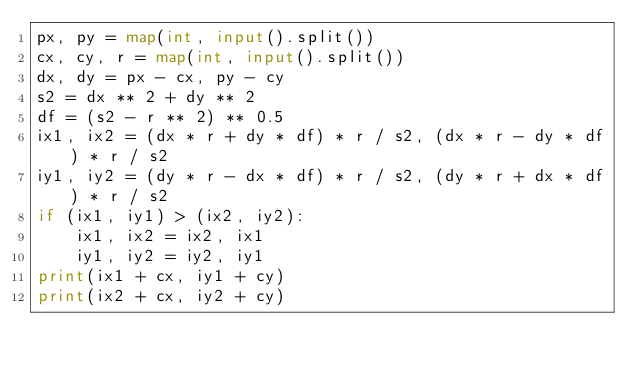Convert code to text. <code><loc_0><loc_0><loc_500><loc_500><_Python_>px, py = map(int, input().split())
cx, cy, r = map(int, input().split())
dx, dy = px - cx, py - cy
s2 = dx ** 2 + dy ** 2
df = (s2 - r ** 2) ** 0.5
ix1, ix2 = (dx * r + dy * df) * r / s2, (dx * r - dy * df) * r / s2
iy1, iy2 = (dy * r - dx * df) * r / s2, (dy * r + dx * df) * r / s2
if (ix1, iy1) > (ix2, iy2):
    ix1, ix2 = ix2, ix1
    iy1, iy2 = iy2, iy1
print(ix1 + cx, iy1 + cy)
print(ix2 + cx, iy2 + cy)
</code> 